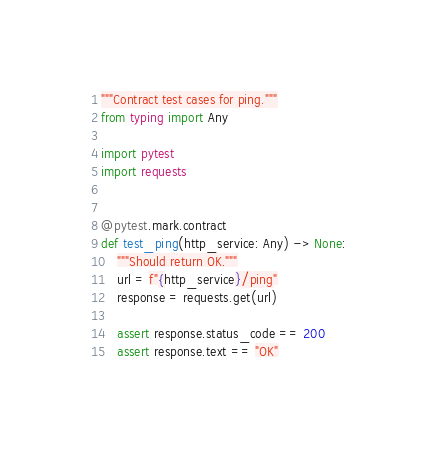<code> <loc_0><loc_0><loc_500><loc_500><_Python_>"""Contract test cases for ping."""
from typing import Any

import pytest
import requests


@pytest.mark.contract
def test_ping(http_service: Any) -> None:
    """Should return OK."""
    url = f"{http_service}/ping"
    response = requests.get(url)

    assert response.status_code == 200
    assert response.text == "OK"
</code> 